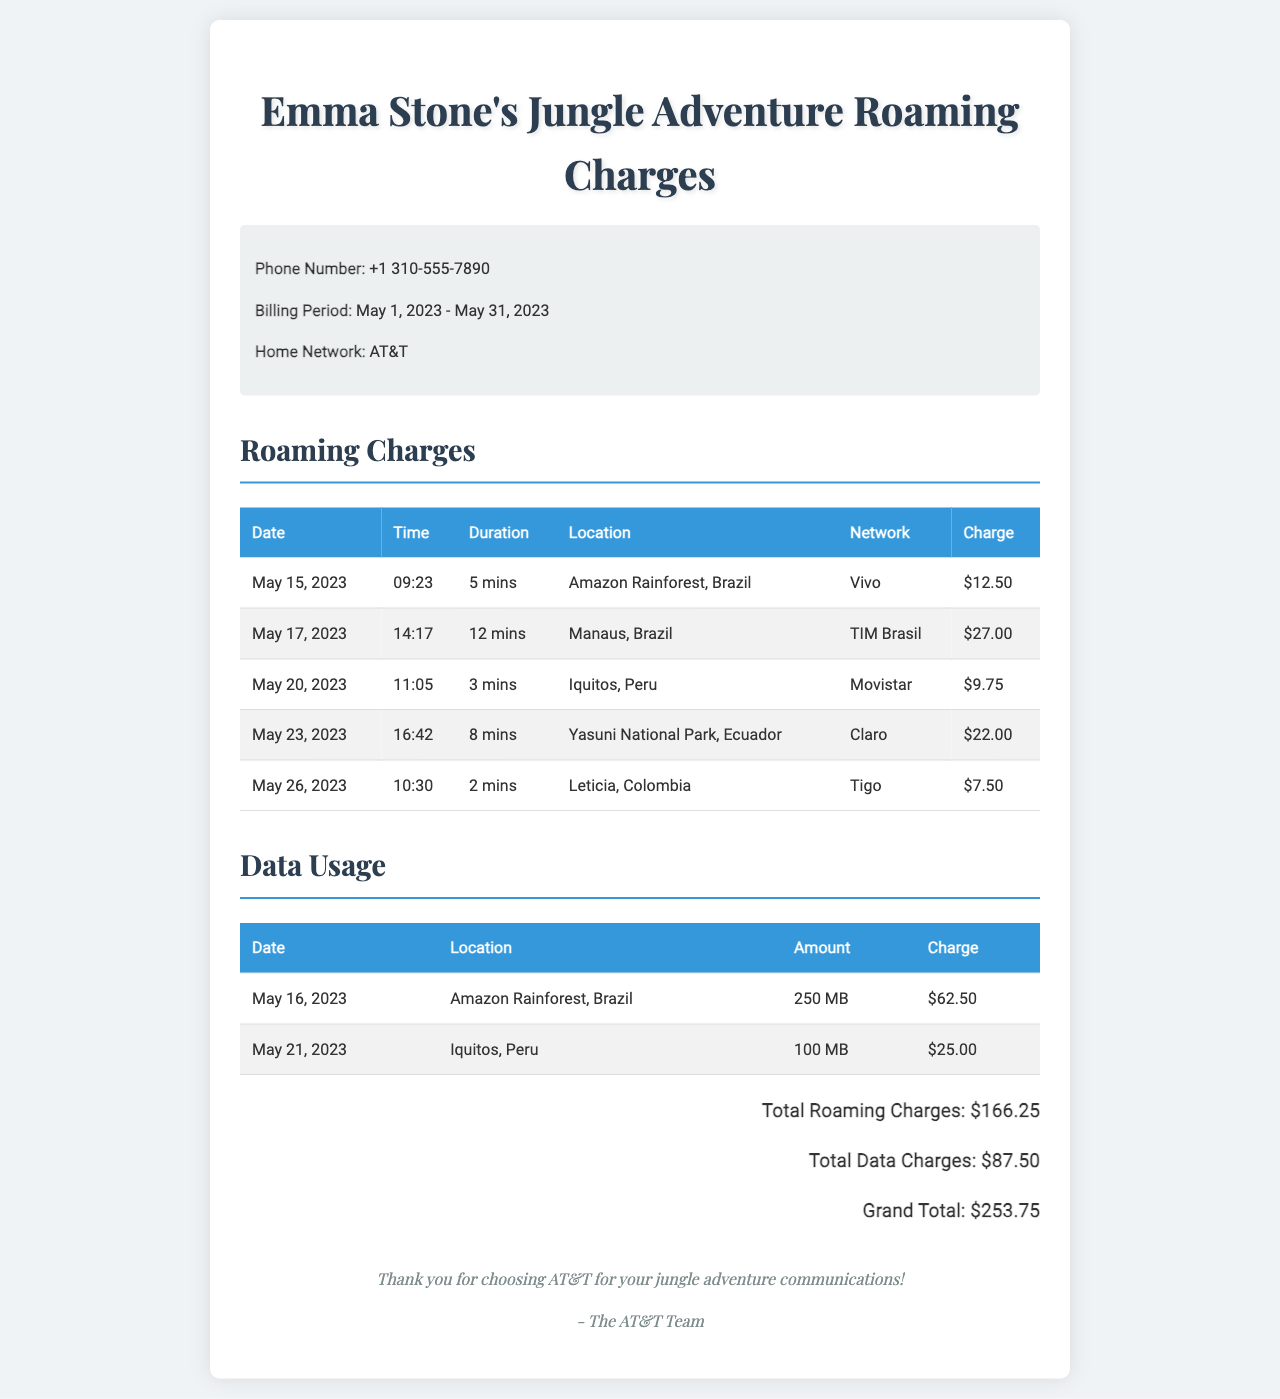What is the billing period? The billing period covers the dates from May 1, 2023 to May 31, 2023 as mentioned in the document.
Answer: May 1, 2023 - May 31, 2023 What is the charge for the call made on May 17, 2023? The document specifies the charge incurred for the call on that date, which amounts to $27.00.
Answer: $27.00 How many minutes did the call on May 20, 2023, last? The duration of the call on May 20, 2023, is explicitly stated as 3 mins in the record.
Answer: 3 mins What location was the call made on May 23, 2023? The location for the call made on this date is specified in the document as Yasuni National Park, Ecuador.
Answer: Yasuni National Park, Ecuador What is the total data charge? The total data charge is indicated in the document after summing the individual data usage charges, which is $87.50.
Answer: $87.50 How much was charged for data usage in the Amazon Rainforest on May 16, 2023? The charge for the data usage in that location and date is provided in the document as $62.50.
Answer: $62.50 What network was used during the call in Leticia, Colombia? The document lists the network utilized for that call as Tigo.
Answer: Tigo What was the grand total of all charges? The grand total combines all roaming and data charges, as stated to be $253.75 in the document.
Answer: $253.75 